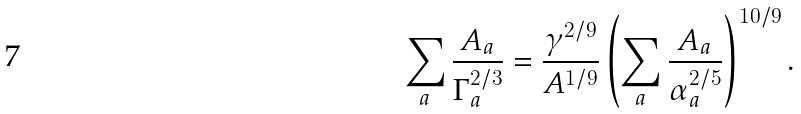<formula> <loc_0><loc_0><loc_500><loc_500>\sum _ { a } \frac { A _ { a } } { \Gamma ^ { 2 / 3 } _ { a } } = \frac { \gamma ^ { 2 / 9 } } { A ^ { 1 / 9 } } \left ( \sum _ { a } \frac { A _ { a } } { \alpha ^ { 2 / 5 } _ { a } } \right ) ^ { 1 0 / 9 } .</formula> 